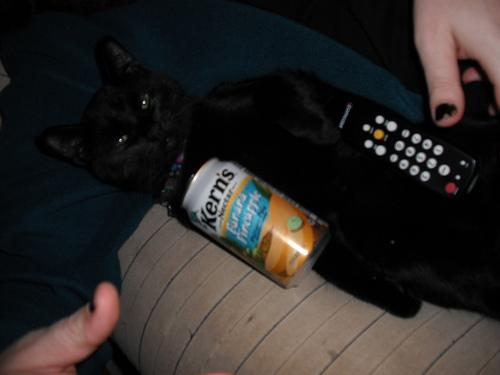The remote control placed on top of the black cat controls what object?

Choices:
A) cable box
B) vcr
C) dvd player
D) television cable box 